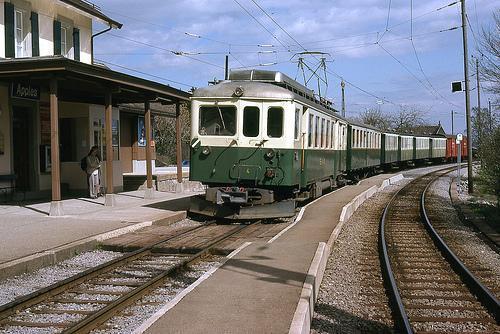How many sets of train tracks are there?
Give a very brief answer. 2. 